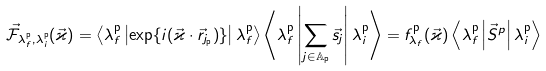<formula> <loc_0><loc_0><loc_500><loc_500>\vec { \mathcal { F } } _ { \lambda _ { f } ^ { \mathrm p } , \lambda _ { i } ^ { \mathrm p } } ( \vec { \varkappa } ) = \left \langle \lambda _ { f } ^ { \mathrm p } \left | \exp \{ i ( \vec { \varkappa } \cdot \vec { r } _ { j _ { \mathrm p } } ) \} \right | \lambda _ { f } ^ { \mathrm p } \right \rangle \left \langle \lambda _ { f } ^ { \mathrm p } \left | \sum _ { j \in \mathbb { A } _ { \mathrm p } } \vec { s } _ { j } \right | \lambda _ { i } ^ { \mathrm p } \right \rangle = f _ { \lambda _ { f } } ^ { \mathrm p } ( \vec { \varkappa } ) \left \langle \lambda _ { f } ^ { \mathrm p } \left | \vec { S } ^ { p } \right | \lambda _ { i } ^ { \mathrm p } \right \rangle</formula> 